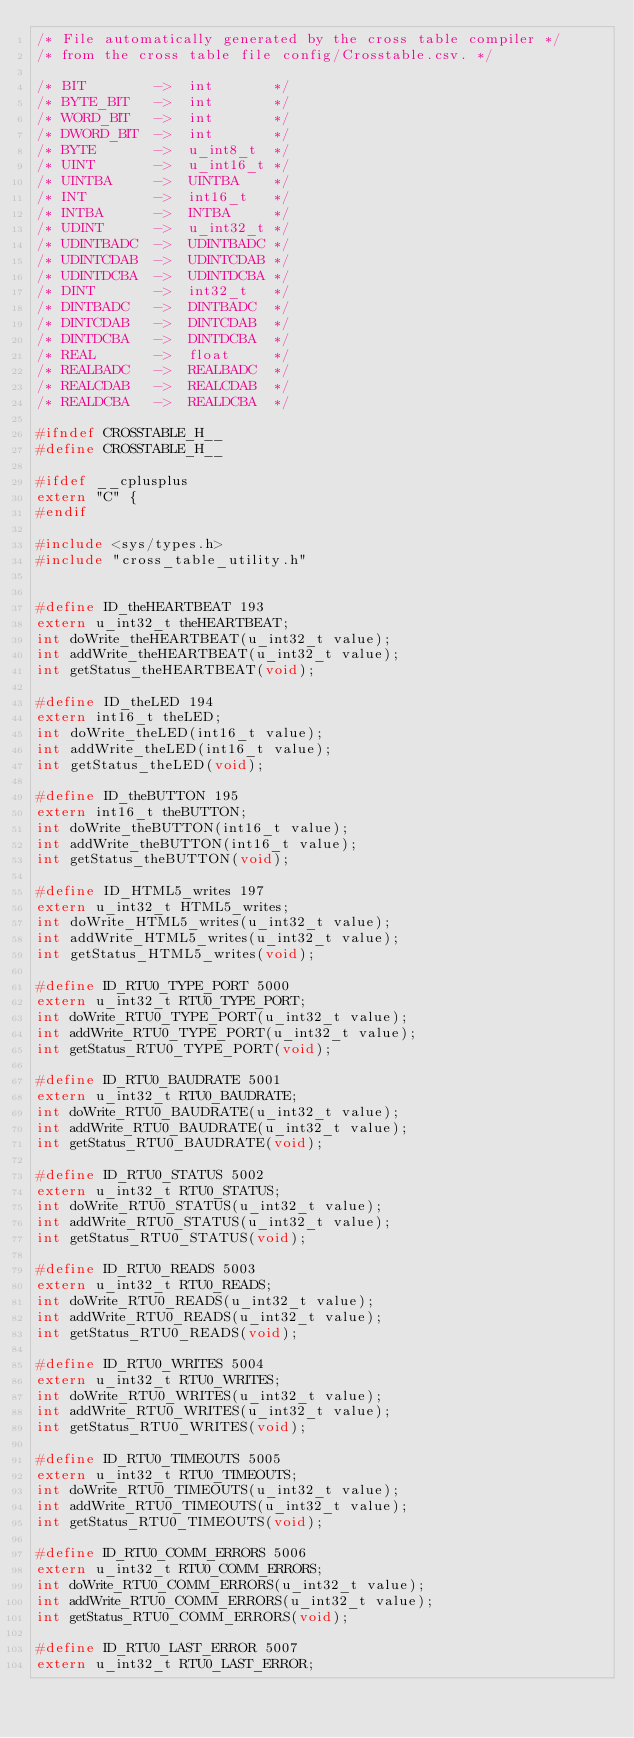Convert code to text. <code><loc_0><loc_0><loc_500><loc_500><_C_>/* File automatically generated by the cross table compiler */
/* from the cross table file config/Crosstable.csv. */

/* BIT        ->  int       */
/* BYTE_BIT   ->  int       */
/* WORD_BIT   ->  int       */
/* DWORD_BIT  ->  int       */
/* BYTE       ->  u_int8_t  */
/* UINT       ->  u_int16_t */
/* UINTBA     ->  UINTBA    */
/* INT        ->  int16_t   */
/* INTBA      ->  INTBA     */
/* UDINT      ->  u_int32_t */
/* UDINTBADC  ->  UDINTBADC */
/* UDINTCDAB  ->  UDINTCDAB */
/* UDINTDCBA  ->  UDINTDCBA */
/* DINT       ->  int32_t   */
/* DINTBADC   ->  DINTBADC  */
/* DINTCDAB   ->  DINTCDAB  */
/* DINTDCBA   ->  DINTDCBA  */
/* REAL       ->  float     */
/* REALBADC   ->  REALBADC  */
/* REALCDAB   ->  REALCDAB  */
/* REALDCBA   ->  REALDCBA  */

#ifndef CROSSTABLE_H__
#define CROSSTABLE_H__

#ifdef __cplusplus
extern "C" {
#endif

#include <sys/types.h>
#include "cross_table_utility.h"


#define ID_theHEARTBEAT 193
extern u_int32_t theHEARTBEAT;
int doWrite_theHEARTBEAT(u_int32_t value);
int addWrite_theHEARTBEAT(u_int32_t value);
int getStatus_theHEARTBEAT(void);

#define ID_theLED 194
extern int16_t theLED;
int doWrite_theLED(int16_t value);
int addWrite_theLED(int16_t value);
int getStatus_theLED(void);

#define ID_theBUTTON 195
extern int16_t theBUTTON;
int doWrite_theBUTTON(int16_t value);
int addWrite_theBUTTON(int16_t value);
int getStatus_theBUTTON(void);

#define ID_HTML5_writes 197
extern u_int32_t HTML5_writes;
int doWrite_HTML5_writes(u_int32_t value);
int addWrite_HTML5_writes(u_int32_t value);
int getStatus_HTML5_writes(void);

#define ID_RTU0_TYPE_PORT 5000
extern u_int32_t RTU0_TYPE_PORT;
int doWrite_RTU0_TYPE_PORT(u_int32_t value);
int addWrite_RTU0_TYPE_PORT(u_int32_t value);
int getStatus_RTU0_TYPE_PORT(void);

#define ID_RTU0_BAUDRATE 5001
extern u_int32_t RTU0_BAUDRATE;
int doWrite_RTU0_BAUDRATE(u_int32_t value);
int addWrite_RTU0_BAUDRATE(u_int32_t value);
int getStatus_RTU0_BAUDRATE(void);

#define ID_RTU0_STATUS 5002
extern u_int32_t RTU0_STATUS;
int doWrite_RTU0_STATUS(u_int32_t value);
int addWrite_RTU0_STATUS(u_int32_t value);
int getStatus_RTU0_STATUS(void);

#define ID_RTU0_READS 5003
extern u_int32_t RTU0_READS;
int doWrite_RTU0_READS(u_int32_t value);
int addWrite_RTU0_READS(u_int32_t value);
int getStatus_RTU0_READS(void);

#define ID_RTU0_WRITES 5004
extern u_int32_t RTU0_WRITES;
int doWrite_RTU0_WRITES(u_int32_t value);
int addWrite_RTU0_WRITES(u_int32_t value);
int getStatus_RTU0_WRITES(void);

#define ID_RTU0_TIMEOUTS 5005
extern u_int32_t RTU0_TIMEOUTS;
int doWrite_RTU0_TIMEOUTS(u_int32_t value);
int addWrite_RTU0_TIMEOUTS(u_int32_t value);
int getStatus_RTU0_TIMEOUTS(void);

#define ID_RTU0_COMM_ERRORS 5006
extern u_int32_t RTU0_COMM_ERRORS;
int doWrite_RTU0_COMM_ERRORS(u_int32_t value);
int addWrite_RTU0_COMM_ERRORS(u_int32_t value);
int getStatus_RTU0_COMM_ERRORS(void);

#define ID_RTU0_LAST_ERROR 5007
extern u_int32_t RTU0_LAST_ERROR;</code> 